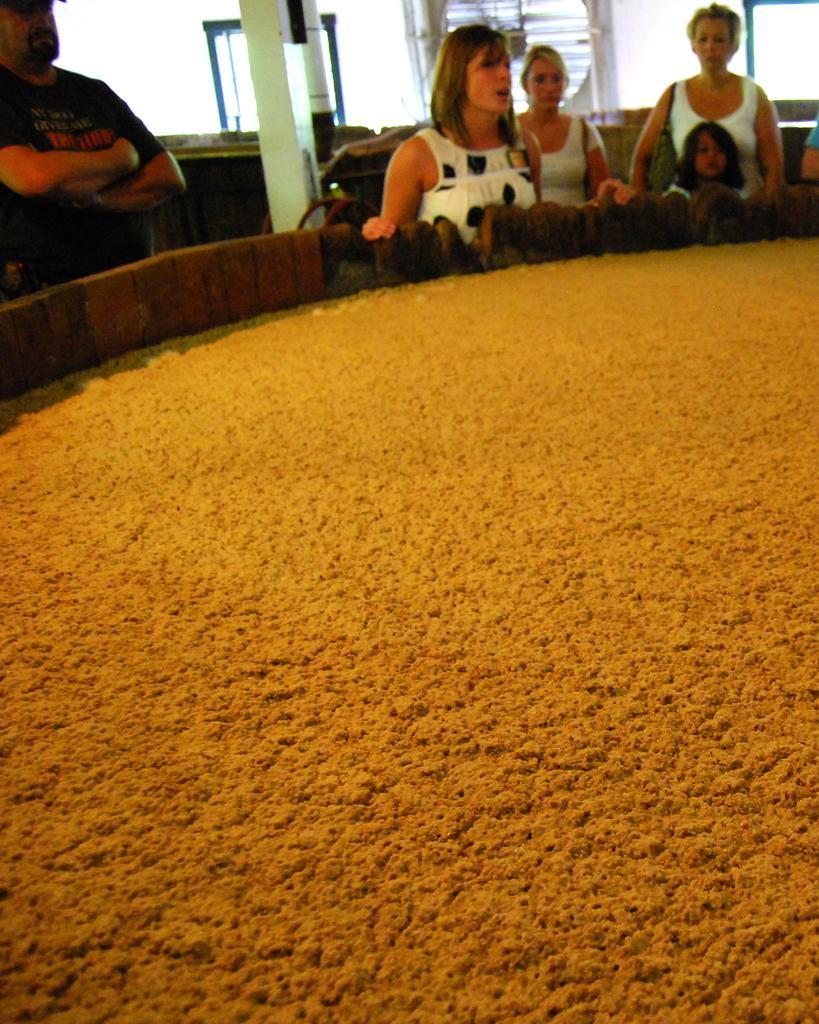Please provide a concise description of this image. In this container we can see food. There are people standing. In the background we can see pillar and windows. 